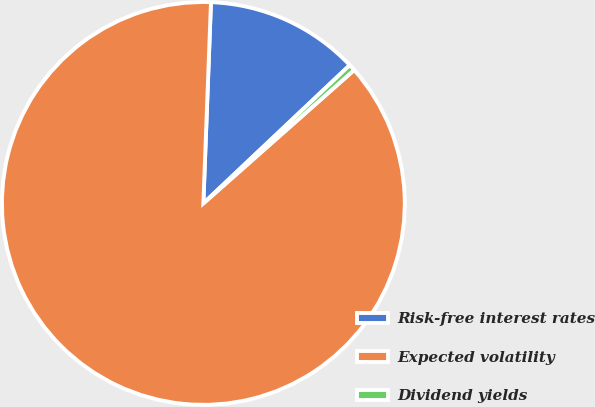Convert chart. <chart><loc_0><loc_0><loc_500><loc_500><pie_chart><fcel>Risk-free interest rates<fcel>Expected volatility<fcel>Dividend yields<nl><fcel>12.35%<fcel>87.13%<fcel>0.52%<nl></chart> 